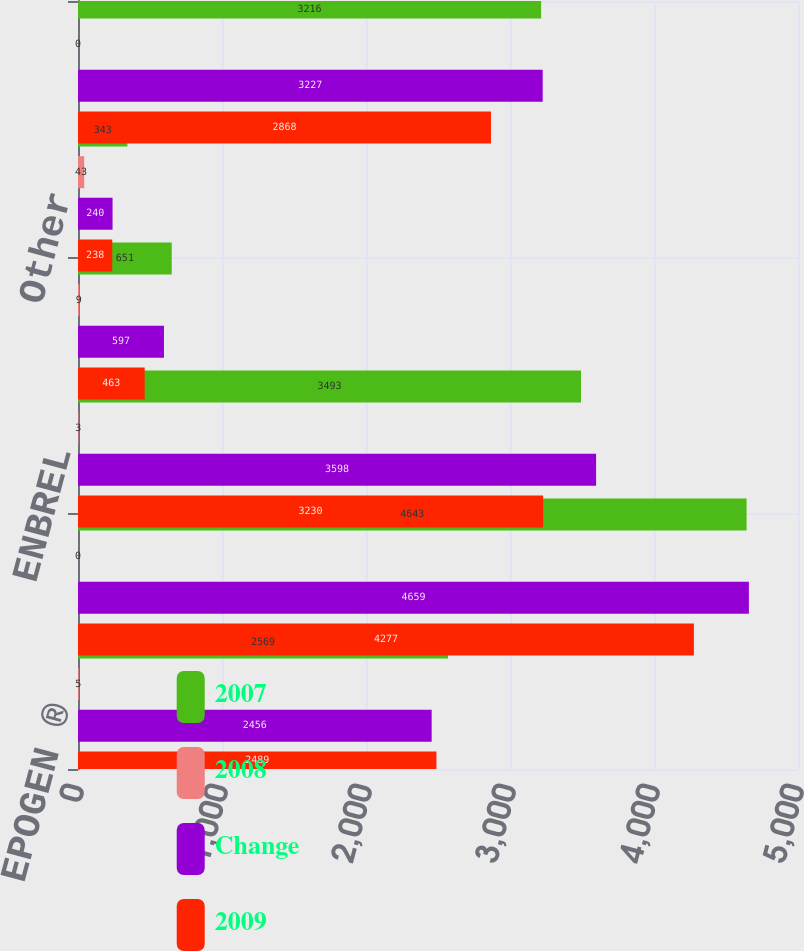Convert chart to OTSL. <chart><loc_0><loc_0><loc_500><loc_500><stacked_bar_chart><ecel><fcel>EPOGEN ®<fcel>Neulasta^®/NEUPOGEN ®<fcel>ENBREL<fcel>Sensipar ®<fcel>Other<fcel>Total International<nl><fcel>2007<fcel>2569<fcel>4643<fcel>3493<fcel>651<fcel>343<fcel>3216<nl><fcel>2008<fcel>5<fcel>0<fcel>3<fcel>9<fcel>43<fcel>0<nl><fcel>Change<fcel>2456<fcel>4659<fcel>3598<fcel>597<fcel>240<fcel>3227<nl><fcel>2009<fcel>2489<fcel>4277<fcel>3230<fcel>463<fcel>238<fcel>2868<nl></chart> 